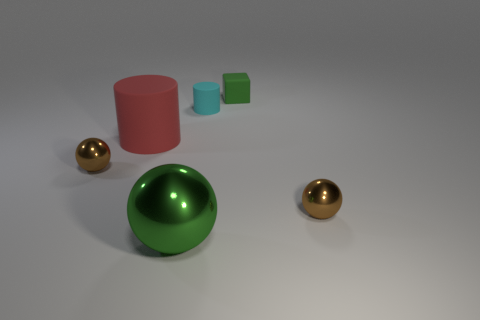Subtract all green spheres. How many spheres are left? 2 Add 1 large cyan rubber spheres. How many objects exist? 7 Subtract all cylinders. How many objects are left? 4 Add 3 metallic objects. How many metallic objects are left? 6 Add 6 small matte blocks. How many small matte blocks exist? 7 Subtract 0 red cubes. How many objects are left? 6 Subtract all rubber spheres. Subtract all tiny matte things. How many objects are left? 4 